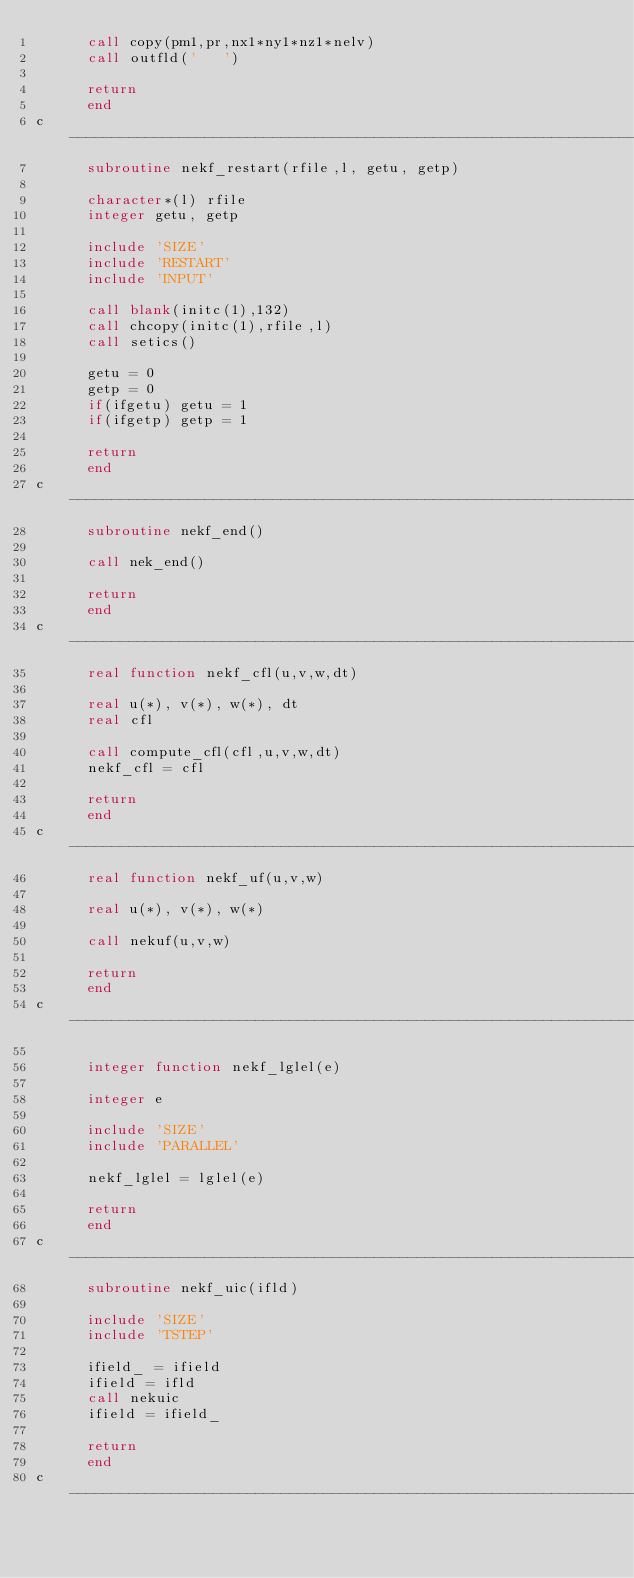Convert code to text. <code><loc_0><loc_0><loc_500><loc_500><_FORTRAN_>      call copy(pm1,pr,nx1*ny1*nz1*nelv)
      call outfld('   ')

      return
      end
c-----------------------------------------------------------------------
      subroutine nekf_restart(rfile,l, getu, getp)

      character*(l) rfile
      integer getu, getp

      include 'SIZE'
      include 'RESTART'
      include 'INPUT'

      call blank(initc(1),132)
      call chcopy(initc(1),rfile,l)
      call setics()

      getu = 0
      getp = 0
      if(ifgetu) getu = 1
      if(ifgetp) getp = 1

      return
      end
c-----------------------------------------------------------------------
      subroutine nekf_end()

      call nek_end()

      return
      end
c-----------------------------------------------------------------------
      real function nekf_cfl(u,v,w,dt)

      real u(*), v(*), w(*), dt
      real cfl

      call compute_cfl(cfl,u,v,w,dt)
      nekf_cfl = cfl

      return
      end
c-----------------------------------------------------------------------
      real function nekf_uf(u,v,w)

      real u(*), v(*), w(*)

      call nekuf(u,v,w)

      return
      end
c-----------------------------------------------------------------------

      integer function nekf_lglel(e)

      integer e

      include 'SIZE'
      include 'PARALLEL'

      nekf_lglel = lglel(e)

      return
      end
c-----------------------------------------------------------------------
      subroutine nekf_uic(ifld)

      include 'SIZE'
      include 'TSTEP'

      ifield_ = ifield
      ifield = ifld
      call nekuic
      ifield = ifield_

      return
      end
c-----------------------------------------------------------------------
</code> 